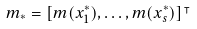<formula> <loc_0><loc_0><loc_500><loc_500>m _ { * } = [ m ( x _ { 1 } ^ { * } ) , \dots , m ( x _ { s } ^ { * } ) ] ^ { \intercal }</formula> 